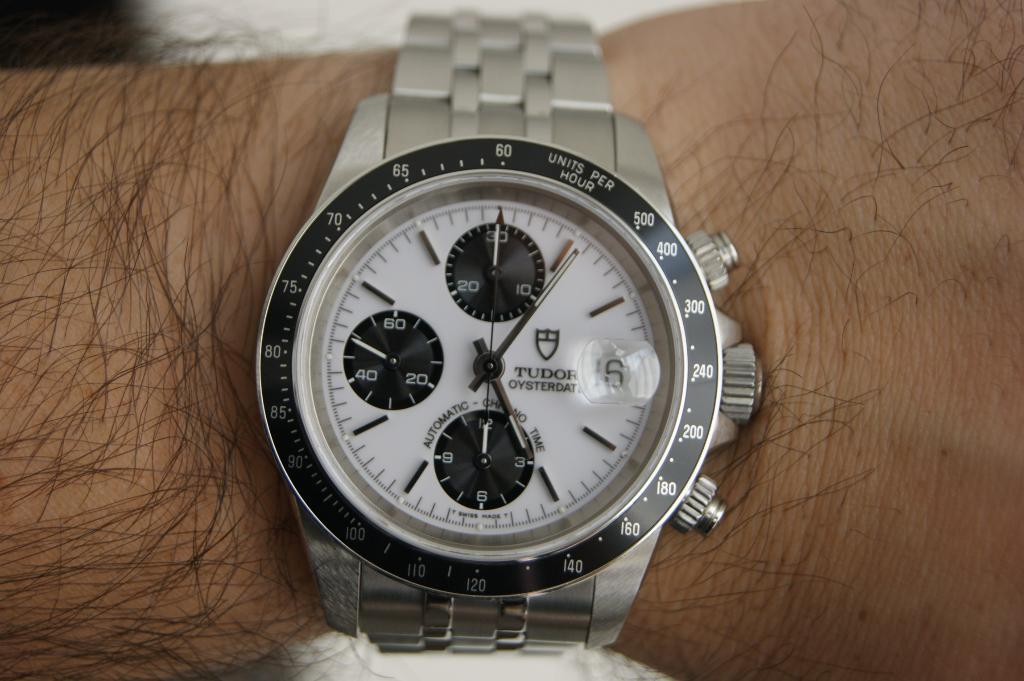<image>
Relay a brief, clear account of the picture shown. A silver and black Tudor Oysterdata watch is displayed on a man's wrist and shows the time as 5:06. 